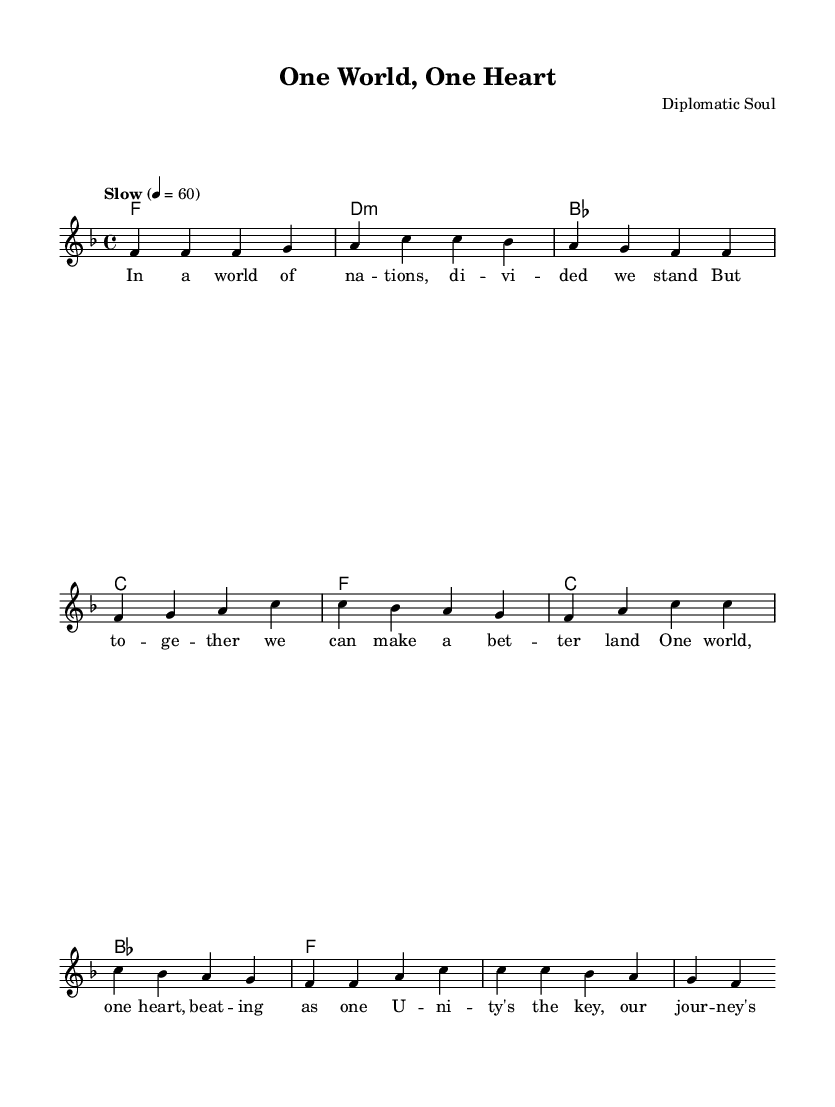What is the key signature of this music? The key signature is F major, which has one flat (B♭). This can be identified by looking at the beginning of the staff where the key signature is notated.
Answer: F major What is the time signature of this piece? The time signature is 4/4, indicated at the beginning of the score. This implies there are four beats per measure, with a quarter note receiving one beat.
Answer: 4/4 What is the tempo marking for this piece? The tempo is marked as "Slow" with a metronome indication of 60 beats per minute. This is visibly noted at the beginning of the score.
Answer: Slow How many verses are present in the score? There is one verse present, as indicated by the lyrics provided under the melody leading into the chorus, all belonging to a single grouped section before the chorus.
Answer: One What are the first four notes of the melody? The first four notes of the melody are F, F, F, G, as seen in the melody line at the beginning. Each note corresponds to a quarter note in the measure.
Answer: F, F, F, G Which chord follows the first measure of the harmonies? The chord that follows the first measure is D minor (d:m) in chord mode after the F major in the first measure, visible in the chord progression.
Answer: D minor 